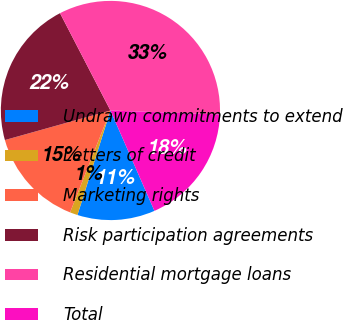<chart> <loc_0><loc_0><loc_500><loc_500><pie_chart><fcel>Undrawn commitments to extend<fcel>Letters of credit<fcel>Marketing rights<fcel>Risk participation agreements<fcel>Residential mortgage loans<fcel>Total<nl><fcel>11.44%<fcel>1.14%<fcel>14.65%<fcel>21.74%<fcel>33.18%<fcel>17.85%<nl></chart> 